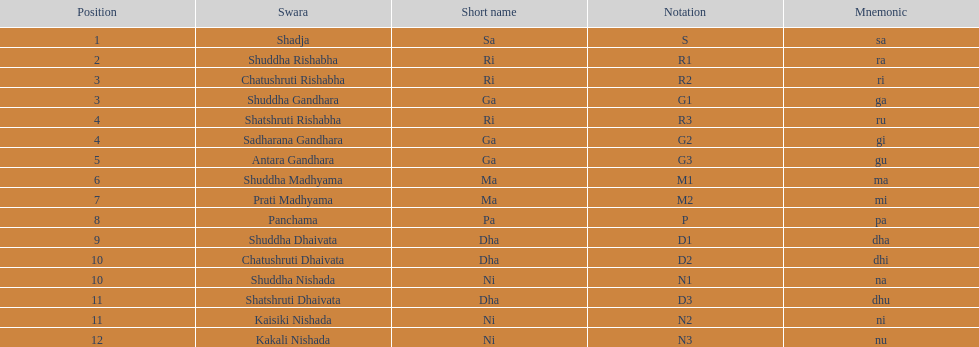Typically, how many swara feature a concise name commencing with d or g? 6. 